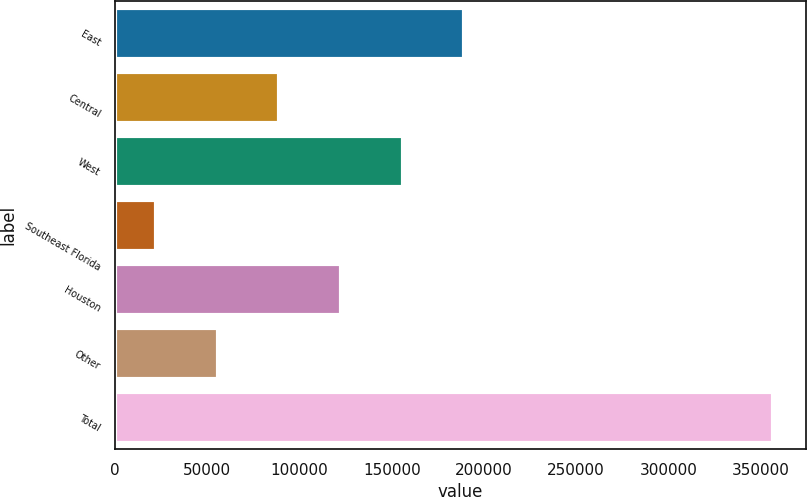Convert chart to OTSL. <chart><loc_0><loc_0><loc_500><loc_500><bar_chart><fcel>East<fcel>Central<fcel>West<fcel>Southeast Florida<fcel>Houston<fcel>Other<fcel>Total<nl><fcel>189368<fcel>89095.8<fcel>155944<fcel>22248<fcel>122520<fcel>55671.9<fcel>356487<nl></chart> 